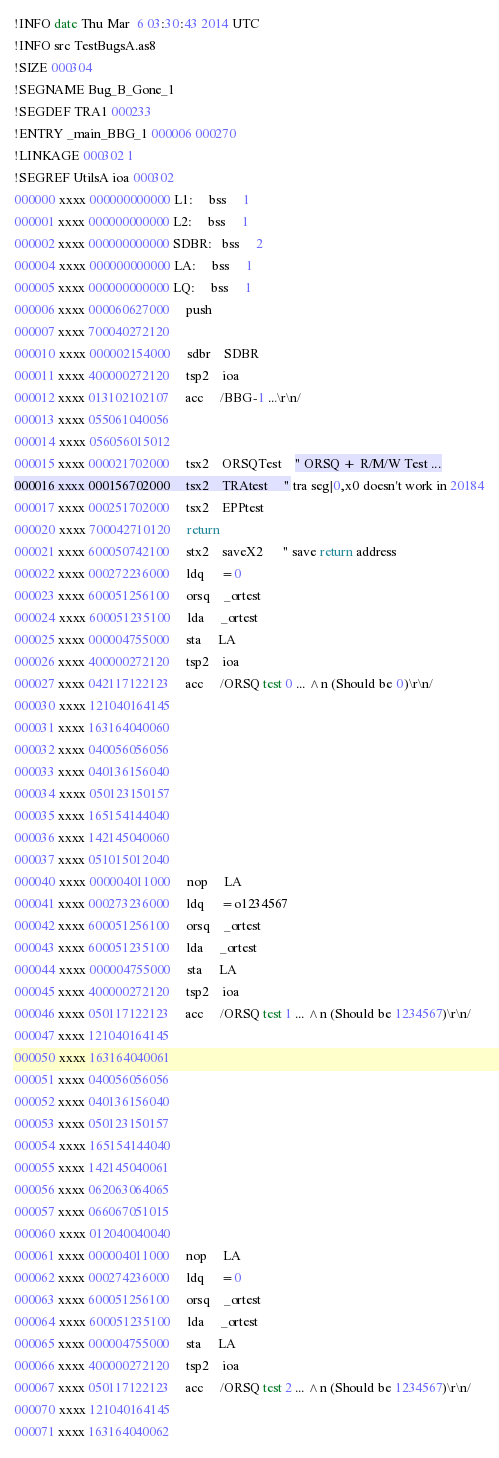Convert code to text. <code><loc_0><loc_0><loc_500><loc_500><_Octave_>!INFO date Thu Mar  6 03:30:43 2014 UTC
!INFO src TestBugsA.as8
!SIZE 000304
!SEGNAME Bug_B_Gone_1
!SEGDEF TRA1 000233
!ENTRY _main_BBG_1 000006 000270
!LINKAGE 000302 1
!SEGREF UtilsA ioa 000302
000000 xxxx 000000000000 L1:     bss     1
000001 xxxx 000000000000 L2:     bss     1
000002 xxxx 000000000000 SDBR:   bss     2
000004 xxxx 000000000000 LA:     bss     1
000005 xxxx 000000000000 LQ:     bss     1
000006 xxxx 000060627000     push
000007 xxxx 700040272120 
000010 xxxx 000002154000     sdbr    SDBR
000011 xxxx 400000272120     tsp2    ioa
000012 xxxx 013102102107     acc     /BBG-1 ...\r\n/
000013 xxxx 055061040056 
000014 xxxx 056056015012 
000015 xxxx 000021702000     tsx2    ORSQTest    " ORSQ + R/M/W Test ...
000016 xxxx 000156702000     tsx2    TRAtest     " tra seg|0,x0 doesn't work in 20184
000017 xxxx 000251702000     tsx2    EPPtest
000020 xxxx 700042710120     return
000021 xxxx 600050742100     stx2    saveX2      " save return address
000022 xxxx 000272236000     ldq     =0
000023 xxxx 600051256100     orsq    _ortest
000024 xxxx 600051235100     lda     _ortest
000025 xxxx 000004755000     sta     LA
000026 xxxx 400000272120     tsp2    ioa
000027 xxxx 042117122123     acc     /ORSQ test 0 ... ^n (Should be 0)\r\n/
000030 xxxx 121040164145 
000031 xxxx 163164040060 
000032 xxxx 040056056056 
000033 xxxx 040136156040 
000034 xxxx 050123150157 
000035 xxxx 165154144040 
000036 xxxx 142145040060 
000037 xxxx 051015012040 
000040 xxxx 000004011000     nop     LA
000041 xxxx 000273236000     ldq     =o1234567
000042 xxxx 600051256100     orsq    _ortest
000043 xxxx 600051235100     lda     _ortest
000044 xxxx 000004755000     sta     LA
000045 xxxx 400000272120     tsp2    ioa
000046 xxxx 050117122123     acc     /ORSQ test 1 ... ^n (Should be 1234567)\r\n/
000047 xxxx 121040164145 
000050 xxxx 163164040061 
000051 xxxx 040056056056 
000052 xxxx 040136156040 
000053 xxxx 050123150157 
000054 xxxx 165154144040 
000055 xxxx 142145040061 
000056 xxxx 062063064065 
000057 xxxx 066067051015 
000060 xxxx 012040040040 
000061 xxxx 000004011000     nop     LA
000062 xxxx 000274236000     ldq     =0
000063 xxxx 600051256100     orsq    _ortest
000064 xxxx 600051235100     lda     _ortest
000065 xxxx 000004755000     sta     LA
000066 xxxx 400000272120     tsp2    ioa
000067 xxxx 050117122123     acc     /ORSQ test 2 ... ^n (Should be 1234567)\r\n/
000070 xxxx 121040164145 
000071 xxxx 163164040062 </code> 